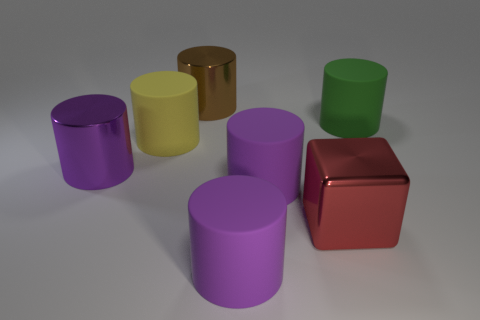What materials do the objects look like they are made of? The objects have a smooth and reflective surface, suggesting they might be made of plastic or some type of metal with a matte finish.  Is there a pattern in the arrangement of the objects? No clear pattern is discernible in the arrangement of the objects. They seem to be placed randomly on the surface. 